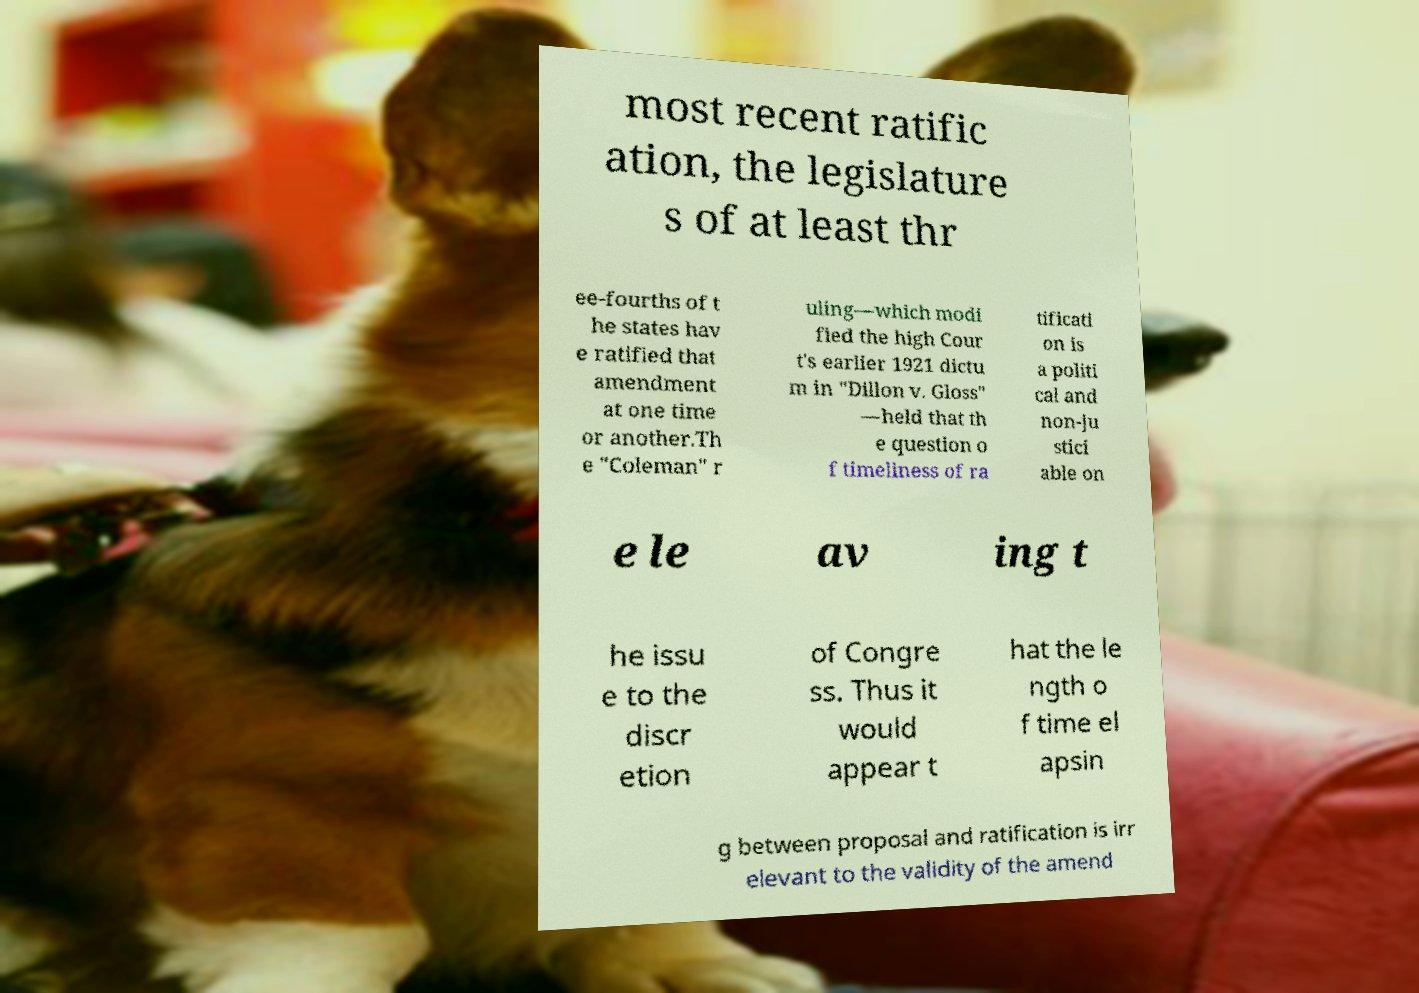Please read and relay the text visible in this image. What does it say? most recent ratific ation, the legislature s of at least thr ee-fourths of t he states hav e ratified that amendment at one time or another.Th e "Coleman" r uling—which modi fied the high Cour t's earlier 1921 dictu m in "Dillon v. Gloss" —held that th e question o f timeliness of ra tificati on is a politi cal and non-ju stici able on e le av ing t he issu e to the discr etion of Congre ss. Thus it would appear t hat the le ngth o f time el apsin g between proposal and ratification is irr elevant to the validity of the amend 